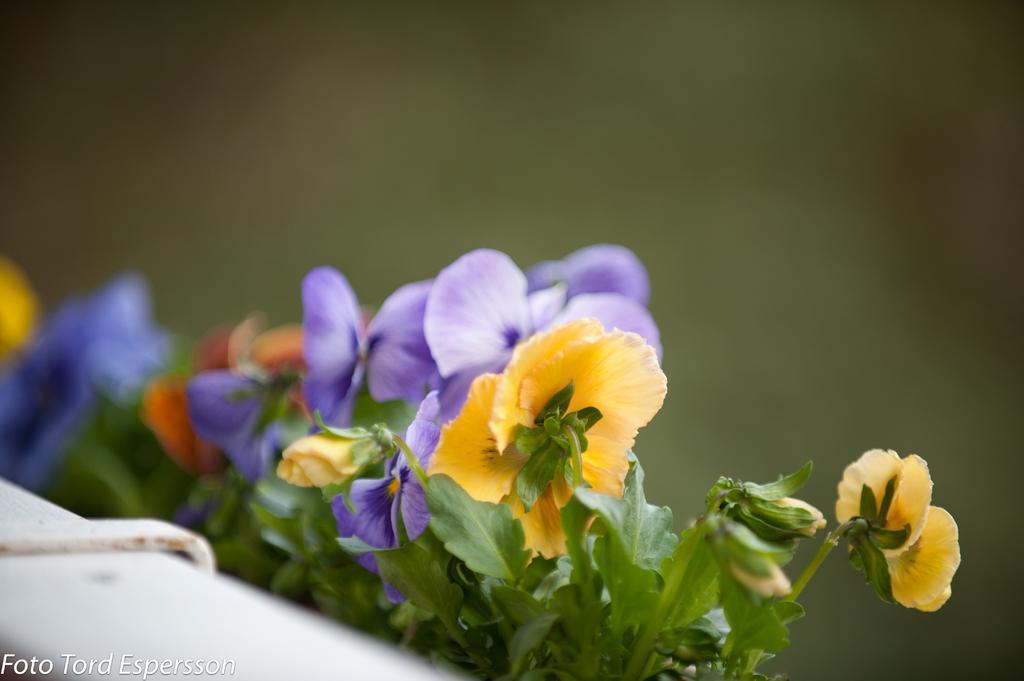How would you summarize this image in a sentence or two? In this image I can see different colors of flowers and green colour leaves in the front. On the bottom left side of the image I can see a watermark. I can also see a white colour thing on the bottom left side and I can see this image is little bit blurry. 